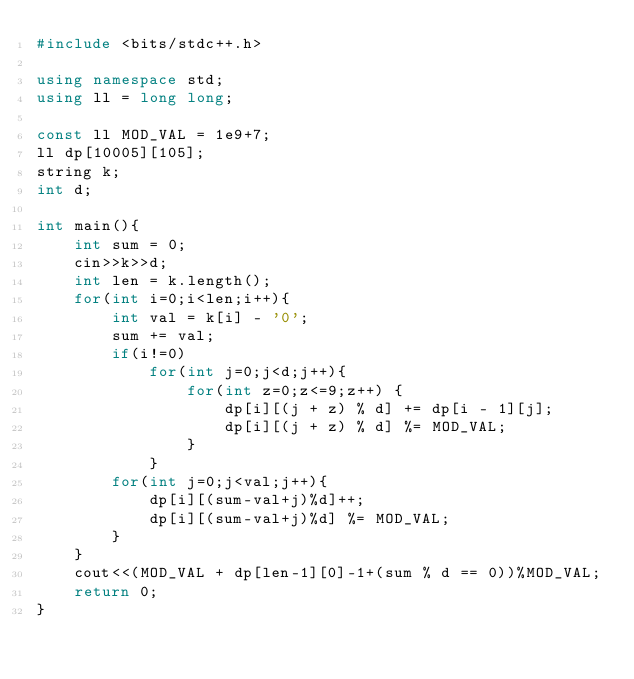<code> <loc_0><loc_0><loc_500><loc_500><_C++_>#include <bits/stdc++.h>

using namespace std;
using ll = long long;

const ll MOD_VAL = 1e9+7;
ll dp[10005][105];
string k;
int d;

int main(){
    int sum = 0;
    cin>>k>>d;
    int len = k.length();
    for(int i=0;i<len;i++){
        int val = k[i] - '0';
        sum += val;
        if(i!=0)
            for(int j=0;j<d;j++){
                for(int z=0;z<=9;z++) {
                    dp[i][(j + z) % d] += dp[i - 1][j];
                    dp[i][(j + z) % d] %= MOD_VAL;
                }
            }
        for(int j=0;j<val;j++){
            dp[i][(sum-val+j)%d]++;
            dp[i][(sum-val+j)%d] %= MOD_VAL;
        }
    }
    cout<<(MOD_VAL + dp[len-1][0]-1+(sum % d == 0))%MOD_VAL;
    return 0;
}</code> 